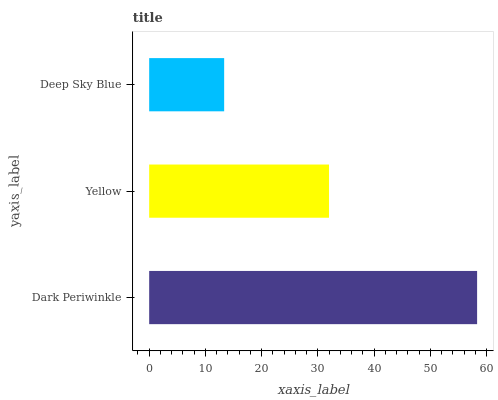Is Deep Sky Blue the minimum?
Answer yes or no. Yes. Is Dark Periwinkle the maximum?
Answer yes or no. Yes. Is Yellow the minimum?
Answer yes or no. No. Is Yellow the maximum?
Answer yes or no. No. Is Dark Periwinkle greater than Yellow?
Answer yes or no. Yes. Is Yellow less than Dark Periwinkle?
Answer yes or no. Yes. Is Yellow greater than Dark Periwinkle?
Answer yes or no. No. Is Dark Periwinkle less than Yellow?
Answer yes or no. No. Is Yellow the high median?
Answer yes or no. Yes. Is Yellow the low median?
Answer yes or no. Yes. Is Deep Sky Blue the high median?
Answer yes or no. No. Is Dark Periwinkle the low median?
Answer yes or no. No. 